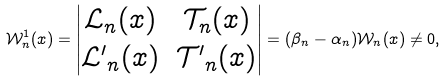<formula> <loc_0><loc_0><loc_500><loc_500>\mathcal { W } ^ { 1 } _ { n } ( x ) = \begin{vmatrix} \mathcal { L } _ { n } ( x ) & \mathcal { T } _ { n } ( x ) \\ \mathcal { L ^ { \prime } } _ { n } ( x ) & \mathcal { T ^ { \prime } } _ { n } ( x ) \end{vmatrix} = ( \beta _ { n } - \alpha _ { n } ) \mathcal { W } _ { n } ( x ) \neq 0 ,</formula> 